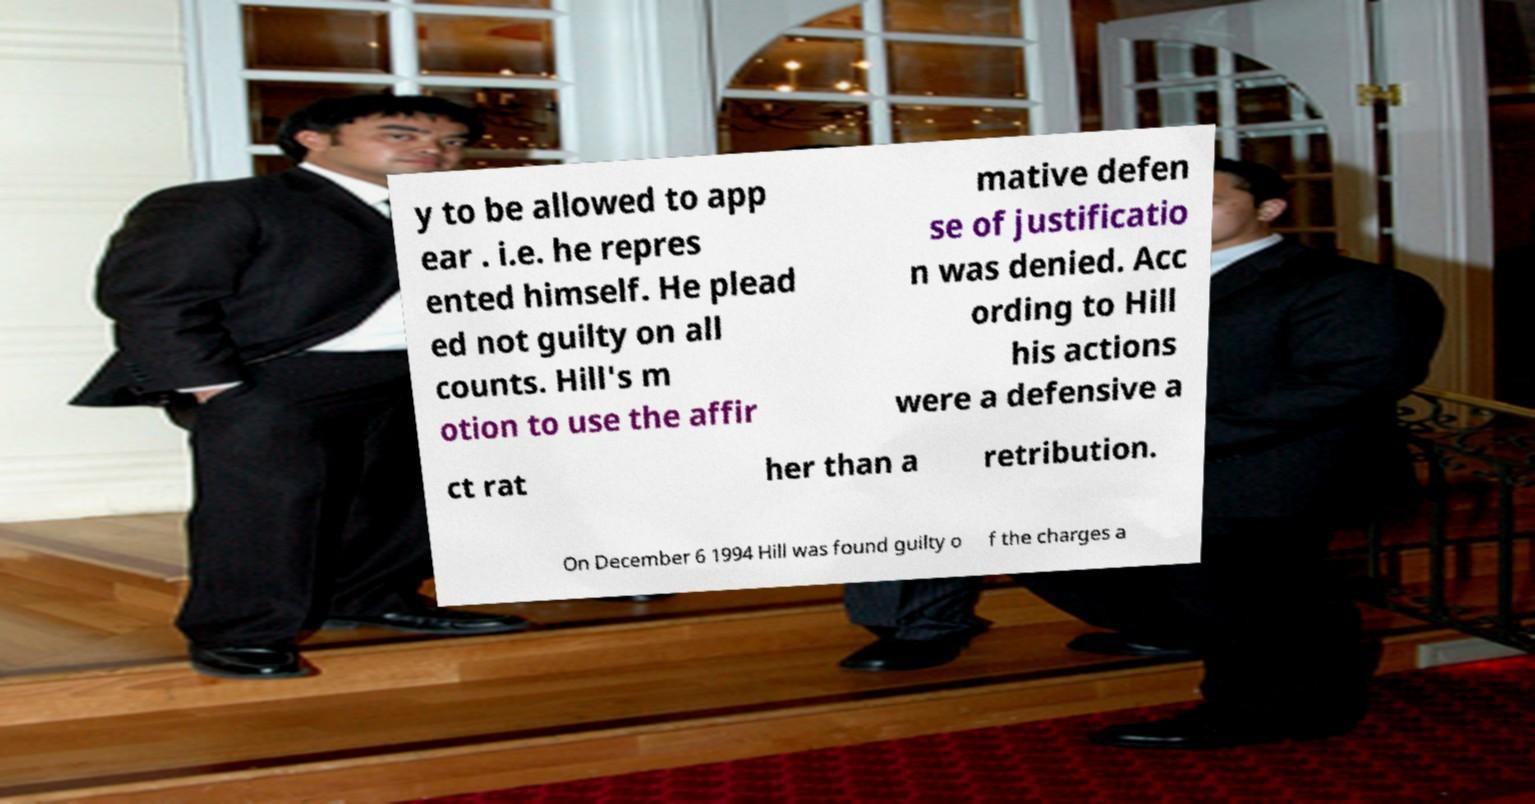For documentation purposes, I need the text within this image transcribed. Could you provide that? y to be allowed to app ear . i.e. he repres ented himself. He plead ed not guilty on all counts. Hill's m otion to use the affir mative defen se of justificatio n was denied. Acc ording to Hill his actions were a defensive a ct rat her than a retribution. On December 6 1994 Hill was found guilty o f the charges a 